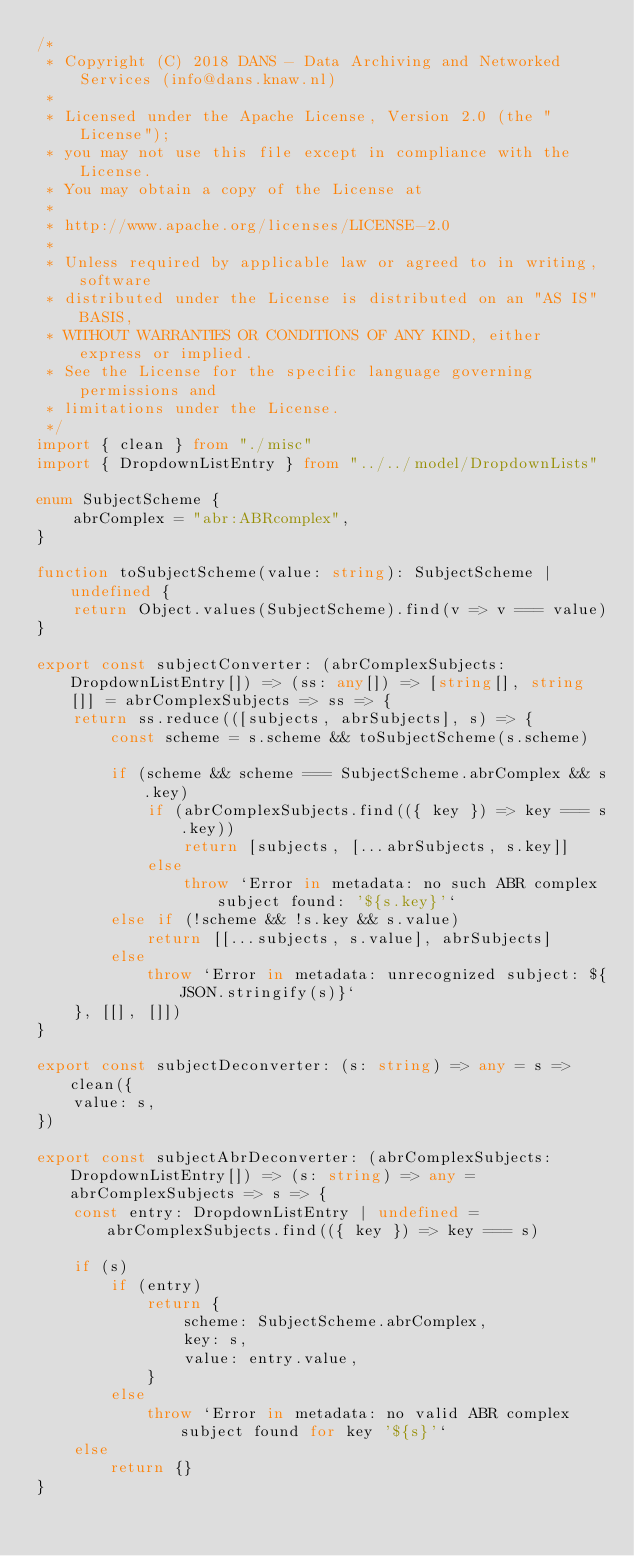Convert code to text. <code><loc_0><loc_0><loc_500><loc_500><_TypeScript_>/*
 * Copyright (C) 2018 DANS - Data Archiving and Networked Services (info@dans.knaw.nl)
 *
 * Licensed under the Apache License, Version 2.0 (the "License");
 * you may not use this file except in compliance with the License.
 * You may obtain a copy of the License at
 *
 * http://www.apache.org/licenses/LICENSE-2.0
 *
 * Unless required by applicable law or agreed to in writing, software
 * distributed under the License is distributed on an "AS IS" BASIS,
 * WITHOUT WARRANTIES OR CONDITIONS OF ANY KIND, either express or implied.
 * See the License for the specific language governing permissions and
 * limitations under the License.
 */
import { clean } from "./misc"
import { DropdownListEntry } from "../../model/DropdownLists"

enum SubjectScheme {
    abrComplex = "abr:ABRcomplex",
}

function toSubjectScheme(value: string): SubjectScheme | undefined {
    return Object.values(SubjectScheme).find(v => v === value)
}

export const subjectConverter: (abrComplexSubjects: DropdownListEntry[]) => (ss: any[]) => [string[], string[]] = abrComplexSubjects => ss => {
    return ss.reduce(([subjects, abrSubjects], s) => {
        const scheme = s.scheme && toSubjectScheme(s.scheme)

        if (scheme && scheme === SubjectScheme.abrComplex && s.key)
            if (abrComplexSubjects.find(({ key }) => key === s.key))
                return [subjects, [...abrSubjects, s.key]]
            else
                throw `Error in metadata: no such ABR complex subject found: '${s.key}'`
        else if (!scheme && !s.key && s.value)
            return [[...subjects, s.value], abrSubjects]
        else
            throw `Error in metadata: unrecognized subject: ${JSON.stringify(s)}`
    }, [[], []])
}

export const subjectDeconverter: (s: string) => any = s => clean({
    value: s,
})

export const subjectAbrDeconverter: (abrComplexSubjects: DropdownListEntry[]) => (s: string) => any = abrComplexSubjects => s => {
    const entry: DropdownListEntry | undefined = abrComplexSubjects.find(({ key }) => key === s)

    if (s)
        if (entry)
            return {
                scheme: SubjectScheme.abrComplex,
                key: s,
                value: entry.value,
            }
        else
            throw `Error in metadata: no valid ABR complex subject found for key '${s}'`
    else
        return {}
}
</code> 